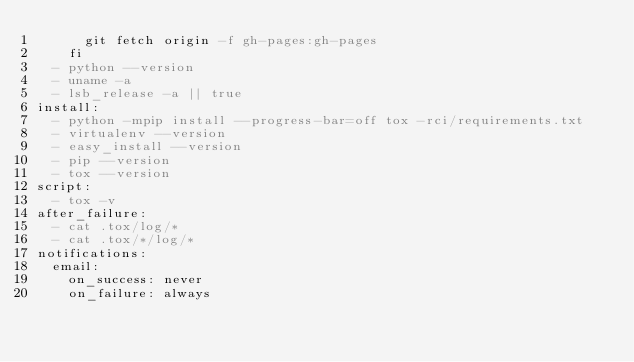<code> <loc_0><loc_0><loc_500><loc_500><_YAML_>      git fetch origin -f gh-pages:gh-pages
    fi
  - python --version
  - uname -a
  - lsb_release -a || true
install:
  - python -mpip install --progress-bar=off tox -rci/requirements.txt
  - virtualenv --version
  - easy_install --version
  - pip --version
  - tox --version
script:
  - tox -v
after_failure:
  - cat .tox/log/*
  - cat .tox/*/log/*
notifications:
  email:
    on_success: never
    on_failure: always
</code> 